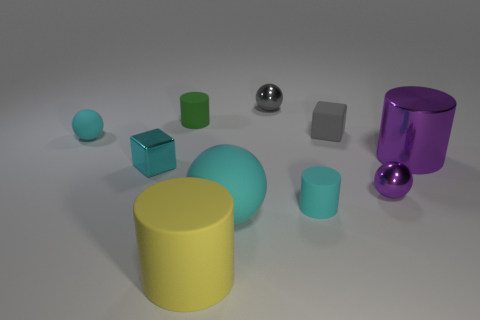Subtract all purple spheres. How many spheres are left? 3 Subtract all spheres. How many objects are left? 6 Subtract all gray cubes. How many cubes are left? 1 Subtract all purple shiny things. Subtract all tiny spheres. How many objects are left? 5 Add 2 cyan cylinders. How many cyan cylinders are left? 3 Add 5 green metallic spheres. How many green metallic spheres exist? 5 Subtract 0 blue balls. How many objects are left? 10 Subtract 4 cylinders. How many cylinders are left? 0 Subtract all red spheres. Subtract all gray cylinders. How many spheres are left? 4 Subtract all yellow cylinders. How many blue balls are left? 0 